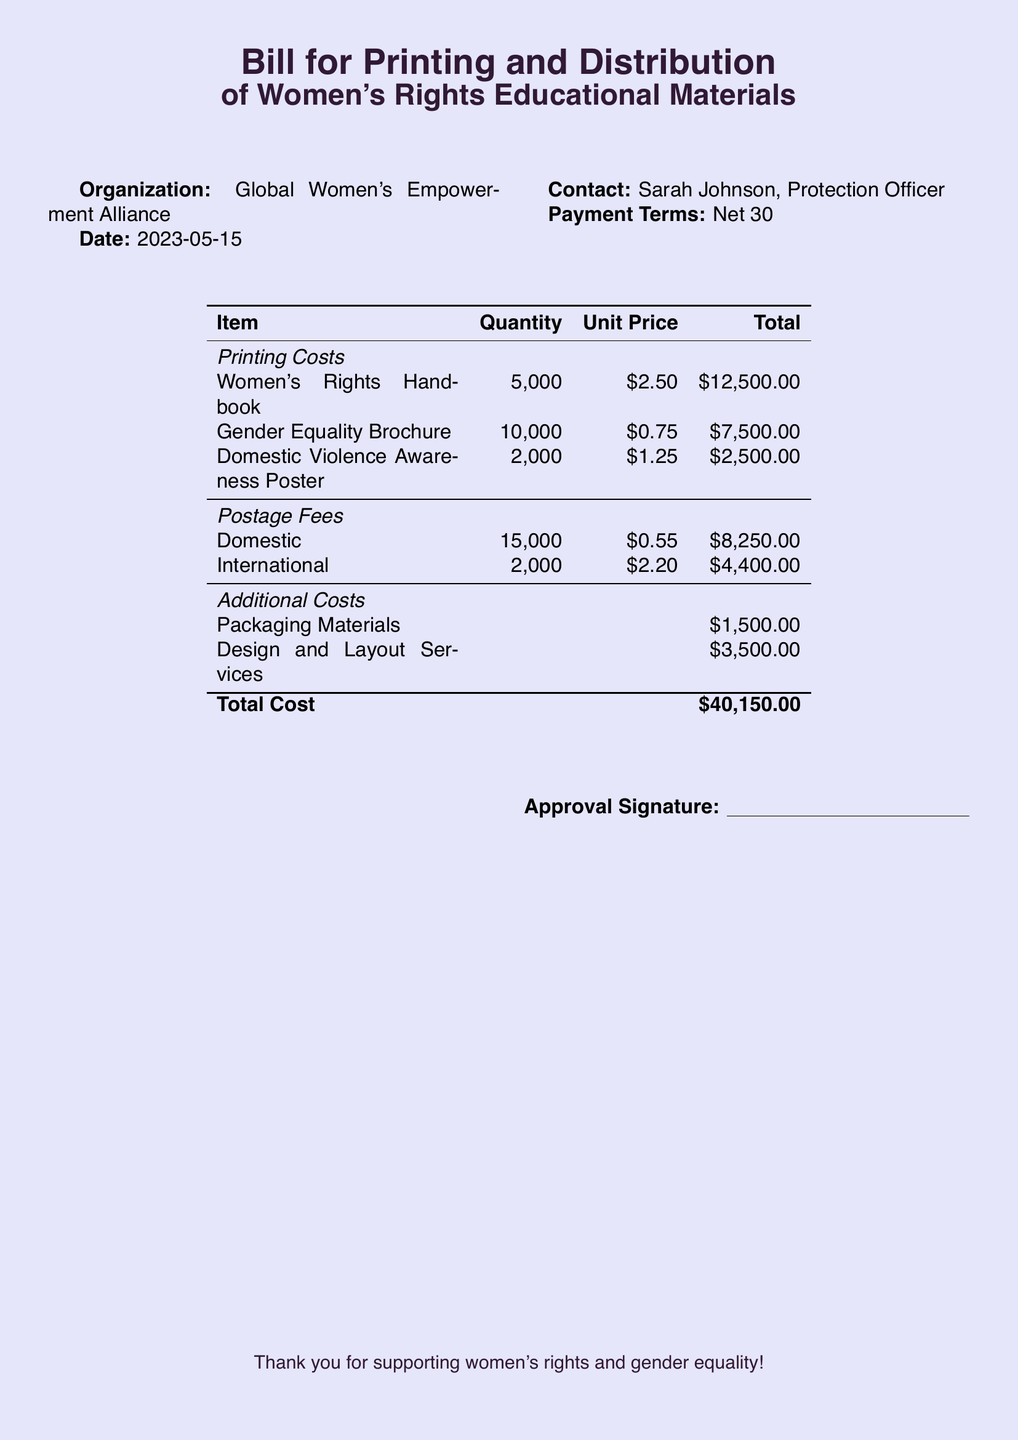What is the name of the organization? The name of the organization is stated at the top of the document.
Answer: Global Women's Empowerment Alliance What is the date of the bill? The date is mentioned near the top of the document under the organization name.
Answer: 2023-05-15 How many Women's Rights Handbooks are to be printed? The quantity for printing is provided in the printing costs table.
Answer: 5,000 What is the unit price of the Gender Equality Brochure? The unit price is listed under the printing costs in the table.
Answer: $0.75 What is the total cost for the Domestic postage fees? The total cost is listed in the postage fees section of the document.
Answer: $8,250.00 What are the additional costs listed in the bill? The additional costs are detailed in the last section of the table.
Answer: Packaging Materials, Design and Layout Services What is the total cost of the project? The total cost is summarized at the bottom of the table.
Answer: $40,150.00 Who is the contact person for this bill? The contact name is provided near the top of the document.
Answer: Sarah Johnson What is the payment term specified in the bill? The payment terms are mentioned at the top of the document.
Answer: Net 30 